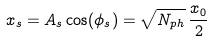Convert formula to latex. <formula><loc_0><loc_0><loc_500><loc_500>x _ { s } = A _ { s } \cos ( \phi _ { s } ) = \sqrt { N _ { p h } } \, \frac { x _ { 0 } } { 2 }</formula> 